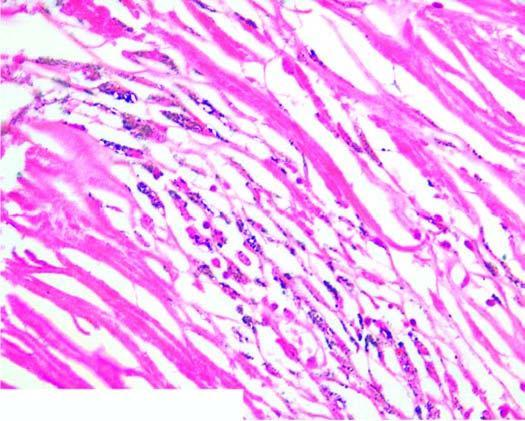does the intervening dermal soft tissue show bright fibres of silica?
Answer the question using a single word or phrase. No 